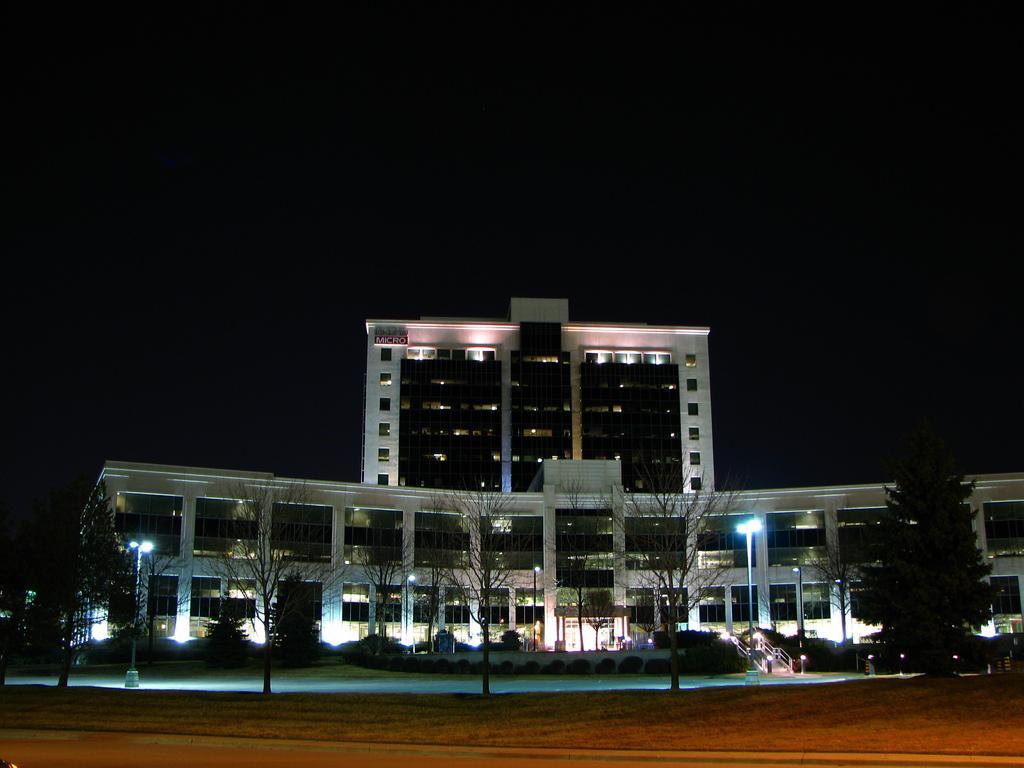Could you give a brief overview of what you see in this image? In this image we can see trees, lights, road, street lights, building and sky. 